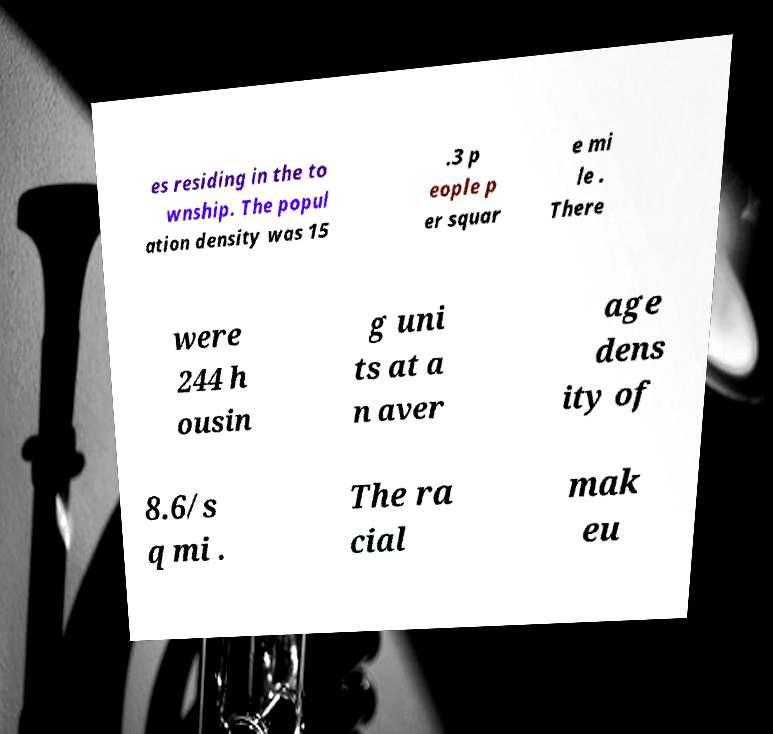Could you extract and type out the text from this image? es residing in the to wnship. The popul ation density was 15 .3 p eople p er squar e mi le . There were 244 h ousin g uni ts at a n aver age dens ity of 8.6/s q mi . The ra cial mak eu 